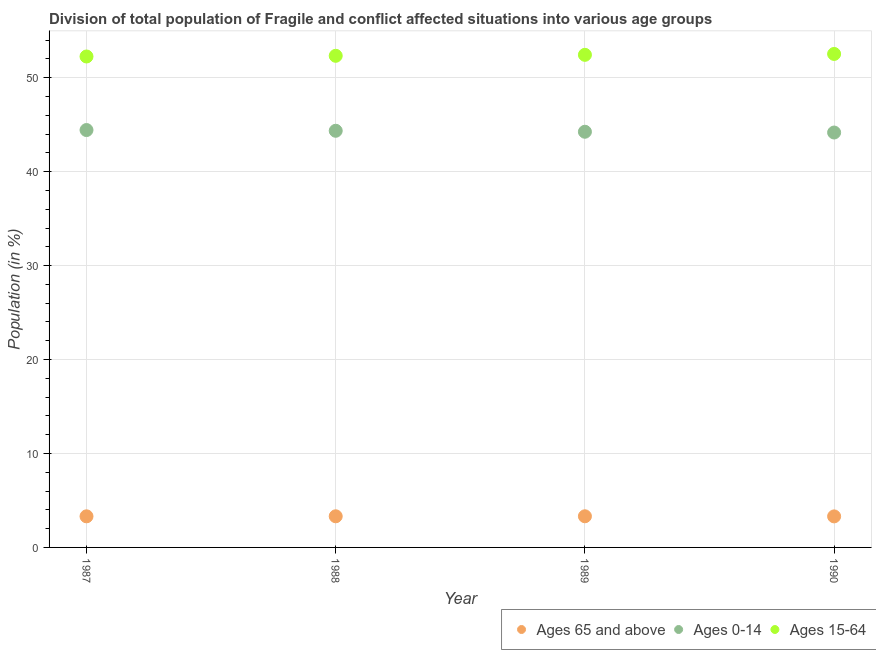What is the percentage of population within the age-group of 65 and above in 1990?
Keep it short and to the point. 3.3. Across all years, what is the maximum percentage of population within the age-group 15-64?
Offer a very short reply. 52.53. Across all years, what is the minimum percentage of population within the age-group 15-64?
Provide a succinct answer. 52.26. In which year was the percentage of population within the age-group 0-14 minimum?
Keep it short and to the point. 1990. What is the total percentage of population within the age-group 15-64 in the graph?
Provide a succinct answer. 209.56. What is the difference between the percentage of population within the age-group 0-14 in 1987 and that in 1990?
Keep it short and to the point. 0.26. What is the difference between the percentage of population within the age-group 15-64 in 1987 and the percentage of population within the age-group of 65 and above in 1990?
Keep it short and to the point. 48.96. What is the average percentage of population within the age-group 15-64 per year?
Keep it short and to the point. 52.39. In the year 1990, what is the difference between the percentage of population within the age-group 15-64 and percentage of population within the age-group 0-14?
Your response must be concise. 8.36. What is the ratio of the percentage of population within the age-group 15-64 in 1988 to that in 1989?
Provide a succinct answer. 1. Is the percentage of population within the age-group of 65 and above in 1987 less than that in 1989?
Give a very brief answer. Yes. What is the difference between the highest and the second highest percentage of population within the age-group 0-14?
Ensure brevity in your answer.  0.08. What is the difference between the highest and the lowest percentage of population within the age-group 0-14?
Provide a short and direct response. 0.26. In how many years, is the percentage of population within the age-group 15-64 greater than the average percentage of population within the age-group 15-64 taken over all years?
Your answer should be very brief. 2. Is the percentage of population within the age-group 15-64 strictly greater than the percentage of population within the age-group of 65 and above over the years?
Your response must be concise. Yes. Are the values on the major ticks of Y-axis written in scientific E-notation?
Ensure brevity in your answer.  No. Does the graph contain grids?
Give a very brief answer. Yes. What is the title of the graph?
Provide a succinct answer. Division of total population of Fragile and conflict affected situations into various age groups
. Does "Labor Tax" appear as one of the legend labels in the graph?
Offer a terse response. No. What is the label or title of the X-axis?
Provide a short and direct response. Year. What is the Population (in %) in Ages 65 and above in 1987?
Give a very brief answer. 3.31. What is the Population (in %) of Ages 0-14 in 1987?
Provide a succinct answer. 44.43. What is the Population (in %) of Ages 15-64 in 1987?
Make the answer very short. 52.26. What is the Population (in %) of Ages 65 and above in 1988?
Keep it short and to the point. 3.32. What is the Population (in %) in Ages 0-14 in 1988?
Ensure brevity in your answer.  44.35. What is the Population (in %) in Ages 15-64 in 1988?
Make the answer very short. 52.33. What is the Population (in %) in Ages 65 and above in 1989?
Provide a short and direct response. 3.32. What is the Population (in %) of Ages 0-14 in 1989?
Your answer should be compact. 44.25. What is the Population (in %) in Ages 15-64 in 1989?
Your response must be concise. 52.44. What is the Population (in %) of Ages 65 and above in 1990?
Provide a succinct answer. 3.3. What is the Population (in %) of Ages 0-14 in 1990?
Your answer should be compact. 44.17. What is the Population (in %) in Ages 15-64 in 1990?
Your answer should be compact. 52.53. Across all years, what is the maximum Population (in %) in Ages 65 and above?
Keep it short and to the point. 3.32. Across all years, what is the maximum Population (in %) of Ages 0-14?
Keep it short and to the point. 44.43. Across all years, what is the maximum Population (in %) in Ages 15-64?
Ensure brevity in your answer.  52.53. Across all years, what is the minimum Population (in %) of Ages 65 and above?
Offer a terse response. 3.3. Across all years, what is the minimum Population (in %) of Ages 0-14?
Provide a short and direct response. 44.17. Across all years, what is the minimum Population (in %) of Ages 15-64?
Offer a very short reply. 52.26. What is the total Population (in %) of Ages 65 and above in the graph?
Ensure brevity in your answer.  13.25. What is the total Population (in %) of Ages 0-14 in the graph?
Ensure brevity in your answer.  177.19. What is the total Population (in %) in Ages 15-64 in the graph?
Make the answer very short. 209.56. What is the difference between the Population (in %) of Ages 65 and above in 1987 and that in 1988?
Your answer should be compact. -0. What is the difference between the Population (in %) in Ages 0-14 in 1987 and that in 1988?
Offer a terse response. 0.08. What is the difference between the Population (in %) of Ages 15-64 in 1987 and that in 1988?
Give a very brief answer. -0.07. What is the difference between the Population (in %) of Ages 65 and above in 1987 and that in 1989?
Your answer should be very brief. -0.01. What is the difference between the Population (in %) of Ages 0-14 in 1987 and that in 1989?
Offer a very short reply. 0.18. What is the difference between the Population (in %) in Ages 15-64 in 1987 and that in 1989?
Give a very brief answer. -0.18. What is the difference between the Population (in %) of Ages 65 and above in 1987 and that in 1990?
Provide a succinct answer. 0.01. What is the difference between the Population (in %) in Ages 0-14 in 1987 and that in 1990?
Make the answer very short. 0.26. What is the difference between the Population (in %) in Ages 15-64 in 1987 and that in 1990?
Ensure brevity in your answer.  -0.27. What is the difference between the Population (in %) of Ages 65 and above in 1988 and that in 1989?
Provide a short and direct response. -0. What is the difference between the Population (in %) in Ages 0-14 in 1988 and that in 1989?
Provide a succinct answer. 0.1. What is the difference between the Population (in %) in Ages 15-64 in 1988 and that in 1989?
Ensure brevity in your answer.  -0.1. What is the difference between the Population (in %) in Ages 65 and above in 1988 and that in 1990?
Offer a terse response. 0.01. What is the difference between the Population (in %) in Ages 0-14 in 1988 and that in 1990?
Give a very brief answer. 0.19. What is the difference between the Population (in %) of Ages 15-64 in 1988 and that in 1990?
Ensure brevity in your answer.  -0.2. What is the difference between the Population (in %) of Ages 65 and above in 1989 and that in 1990?
Make the answer very short. 0.01. What is the difference between the Population (in %) in Ages 0-14 in 1989 and that in 1990?
Offer a terse response. 0.08. What is the difference between the Population (in %) of Ages 15-64 in 1989 and that in 1990?
Provide a succinct answer. -0.09. What is the difference between the Population (in %) of Ages 65 and above in 1987 and the Population (in %) of Ages 0-14 in 1988?
Make the answer very short. -41.04. What is the difference between the Population (in %) in Ages 65 and above in 1987 and the Population (in %) in Ages 15-64 in 1988?
Provide a succinct answer. -49.02. What is the difference between the Population (in %) of Ages 0-14 in 1987 and the Population (in %) of Ages 15-64 in 1988?
Offer a very short reply. -7.9. What is the difference between the Population (in %) in Ages 65 and above in 1987 and the Population (in %) in Ages 0-14 in 1989?
Provide a succinct answer. -40.94. What is the difference between the Population (in %) in Ages 65 and above in 1987 and the Population (in %) in Ages 15-64 in 1989?
Your response must be concise. -49.13. What is the difference between the Population (in %) in Ages 0-14 in 1987 and the Population (in %) in Ages 15-64 in 1989?
Provide a short and direct response. -8.01. What is the difference between the Population (in %) in Ages 65 and above in 1987 and the Population (in %) in Ages 0-14 in 1990?
Your response must be concise. -40.86. What is the difference between the Population (in %) in Ages 65 and above in 1987 and the Population (in %) in Ages 15-64 in 1990?
Provide a short and direct response. -49.22. What is the difference between the Population (in %) in Ages 0-14 in 1987 and the Population (in %) in Ages 15-64 in 1990?
Give a very brief answer. -8.1. What is the difference between the Population (in %) in Ages 65 and above in 1988 and the Population (in %) in Ages 0-14 in 1989?
Ensure brevity in your answer.  -40.93. What is the difference between the Population (in %) in Ages 65 and above in 1988 and the Population (in %) in Ages 15-64 in 1989?
Keep it short and to the point. -49.12. What is the difference between the Population (in %) of Ages 0-14 in 1988 and the Population (in %) of Ages 15-64 in 1989?
Make the answer very short. -8.09. What is the difference between the Population (in %) of Ages 65 and above in 1988 and the Population (in %) of Ages 0-14 in 1990?
Your answer should be compact. -40.85. What is the difference between the Population (in %) of Ages 65 and above in 1988 and the Population (in %) of Ages 15-64 in 1990?
Offer a terse response. -49.22. What is the difference between the Population (in %) in Ages 0-14 in 1988 and the Population (in %) in Ages 15-64 in 1990?
Your answer should be very brief. -8.18. What is the difference between the Population (in %) in Ages 65 and above in 1989 and the Population (in %) in Ages 0-14 in 1990?
Offer a terse response. -40.85. What is the difference between the Population (in %) in Ages 65 and above in 1989 and the Population (in %) in Ages 15-64 in 1990?
Make the answer very short. -49.21. What is the difference between the Population (in %) in Ages 0-14 in 1989 and the Population (in %) in Ages 15-64 in 1990?
Offer a terse response. -8.28. What is the average Population (in %) of Ages 65 and above per year?
Your response must be concise. 3.31. What is the average Population (in %) in Ages 0-14 per year?
Offer a terse response. 44.3. What is the average Population (in %) of Ages 15-64 per year?
Make the answer very short. 52.39. In the year 1987, what is the difference between the Population (in %) of Ages 65 and above and Population (in %) of Ages 0-14?
Ensure brevity in your answer.  -41.12. In the year 1987, what is the difference between the Population (in %) in Ages 65 and above and Population (in %) in Ages 15-64?
Provide a succinct answer. -48.95. In the year 1987, what is the difference between the Population (in %) of Ages 0-14 and Population (in %) of Ages 15-64?
Provide a succinct answer. -7.83. In the year 1988, what is the difference between the Population (in %) in Ages 65 and above and Population (in %) in Ages 0-14?
Offer a terse response. -41.04. In the year 1988, what is the difference between the Population (in %) in Ages 65 and above and Population (in %) in Ages 15-64?
Your answer should be compact. -49.02. In the year 1988, what is the difference between the Population (in %) of Ages 0-14 and Population (in %) of Ages 15-64?
Your answer should be very brief. -7.98. In the year 1989, what is the difference between the Population (in %) in Ages 65 and above and Population (in %) in Ages 0-14?
Give a very brief answer. -40.93. In the year 1989, what is the difference between the Population (in %) of Ages 65 and above and Population (in %) of Ages 15-64?
Make the answer very short. -49.12. In the year 1989, what is the difference between the Population (in %) of Ages 0-14 and Population (in %) of Ages 15-64?
Offer a terse response. -8.19. In the year 1990, what is the difference between the Population (in %) of Ages 65 and above and Population (in %) of Ages 0-14?
Ensure brevity in your answer.  -40.86. In the year 1990, what is the difference between the Population (in %) of Ages 65 and above and Population (in %) of Ages 15-64?
Ensure brevity in your answer.  -49.23. In the year 1990, what is the difference between the Population (in %) of Ages 0-14 and Population (in %) of Ages 15-64?
Your answer should be compact. -8.36. What is the ratio of the Population (in %) in Ages 0-14 in 1987 to that in 1988?
Provide a short and direct response. 1. What is the ratio of the Population (in %) in Ages 65 and above in 1987 to that in 1989?
Provide a short and direct response. 1. What is the ratio of the Population (in %) of Ages 65 and above in 1987 to that in 1990?
Provide a short and direct response. 1. What is the ratio of the Population (in %) in Ages 0-14 in 1987 to that in 1990?
Make the answer very short. 1.01. What is the ratio of the Population (in %) of Ages 65 and above in 1988 to that in 1989?
Give a very brief answer. 1. What is the ratio of the Population (in %) in Ages 0-14 in 1988 to that in 1989?
Provide a succinct answer. 1. What is the ratio of the Population (in %) in Ages 65 and above in 1988 to that in 1990?
Offer a terse response. 1. What is the ratio of the Population (in %) in Ages 15-64 in 1988 to that in 1990?
Offer a very short reply. 1. What is the ratio of the Population (in %) in Ages 65 and above in 1989 to that in 1990?
Make the answer very short. 1. What is the ratio of the Population (in %) of Ages 15-64 in 1989 to that in 1990?
Make the answer very short. 1. What is the difference between the highest and the second highest Population (in %) in Ages 65 and above?
Make the answer very short. 0. What is the difference between the highest and the second highest Population (in %) in Ages 0-14?
Offer a very short reply. 0.08. What is the difference between the highest and the second highest Population (in %) of Ages 15-64?
Keep it short and to the point. 0.09. What is the difference between the highest and the lowest Population (in %) in Ages 65 and above?
Your answer should be very brief. 0.01. What is the difference between the highest and the lowest Population (in %) of Ages 0-14?
Your answer should be compact. 0.26. What is the difference between the highest and the lowest Population (in %) in Ages 15-64?
Ensure brevity in your answer.  0.27. 